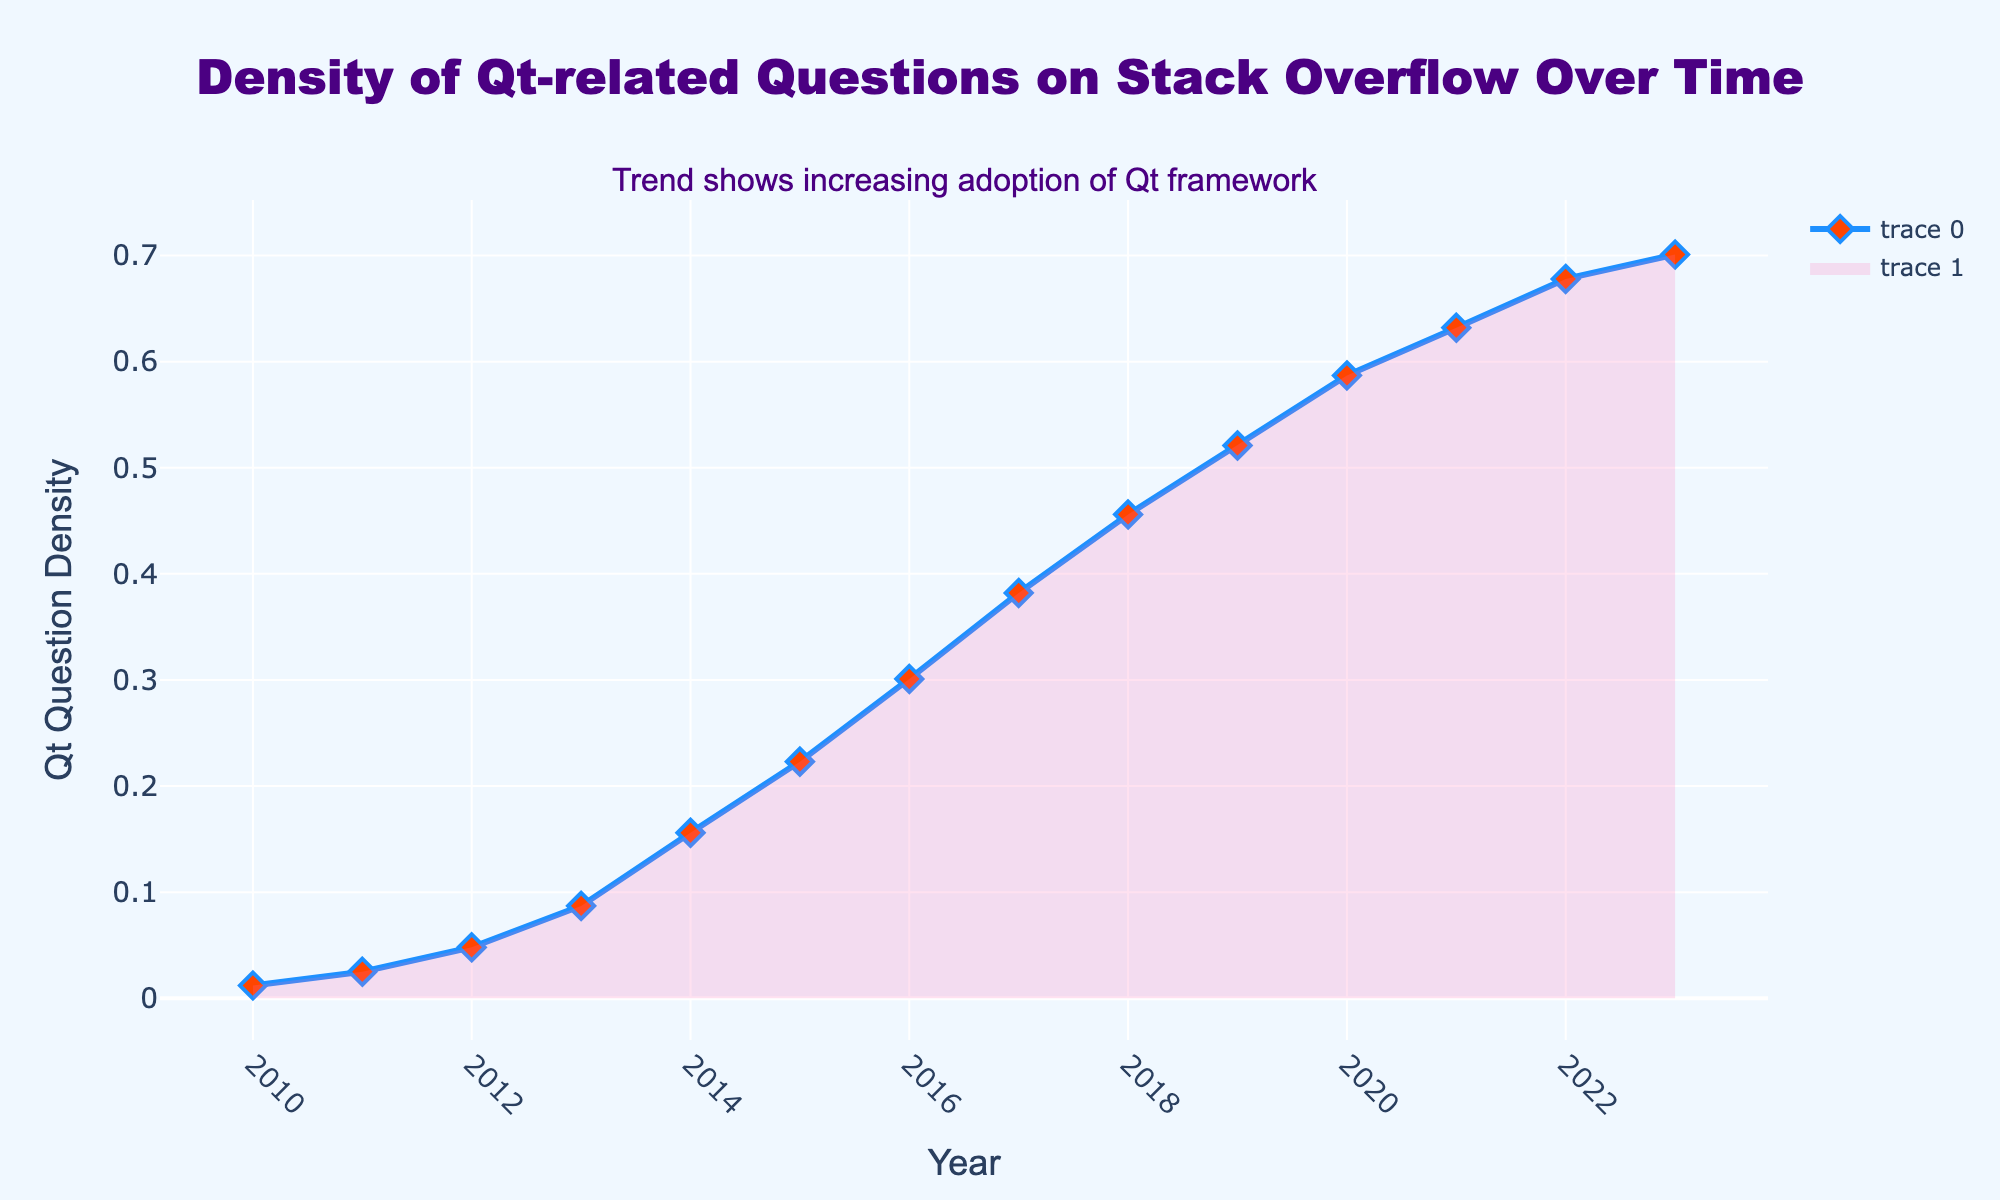What is the title of the plot? To find the title of the plot, look at the top section of the figure. The text there reads "Density of Qt-related Questions on Stack Overflow Over Time".
Answer: Density of Qt-related Questions on Stack Overflow Over Time In which year did the density of Qt-related questions first surpass 0.1? To determine when the density first surpassed 0.1, observe the y-axis, and find the point where the density value is greater than 0.1. This happens in 2013.
Answer: 2013 Between which two consecutive years did the density of Qt-related questions have the largest increase? To identify the largest increase between two consecutive years, calculate the differences in densities year over year and compare them. The increase between 2013 and 2014 is 0.156 - 0.087 = 0.069, which is the largest.
Answer: 2013 and 2014 How many data points are represented in the plot? Count the number of markers along the line in the plot, each marker represents a data point. The data ranges from 2010 to 2023.
Answer: 14 Describe the overall trend of Qt-related question density over time. Look at the line plot from 2010 to 2023. The density increases steadily over time, showing a continuous growth pattern. The annotation confirms this trend by stating "Trend shows increasing adoption of Qt framework".
Answer: Steadily increasing Which year marks the peak density in the provided data? Refer to the highest point on the y-axis along the plotted line. The peak density, 0.701, occurs in 2023.
Answer: 2023 What can be inferred from the gradient fill color under the line plot? The gradient fill, which transitions from pink to light pink, signifies the area under the curve, emphasizing the growing influence without obscuring the main line plot. The fill serves a decorative purpose to enhance visual understanding.
Answer: Emphasizes growth visually What color is the line representing Qt question density and its markers? Inspect the line and the markers on the plot. The line is blue, and the markers (diamond symbols) are orange with a blue outline.
Answer: Blue line and orange markers with blue outline By how much did the density of Qt-related questions increase between 2012 and 2020? First, find the density values for 2012 (0.048) and 2020 (0.587). The difference is calculated as 0.587 - 0.048 = 0.539.
Answer: 0.539 What annotation is added to the plot, and where is it located? Observe the additional text on the plot which is placed near the top. The annotation reads "Trend shows increasing adoption of Qt framework" and is positioned slightly above the title.
Answer: Trend shows increasing adoption of Qt framework, above the title 